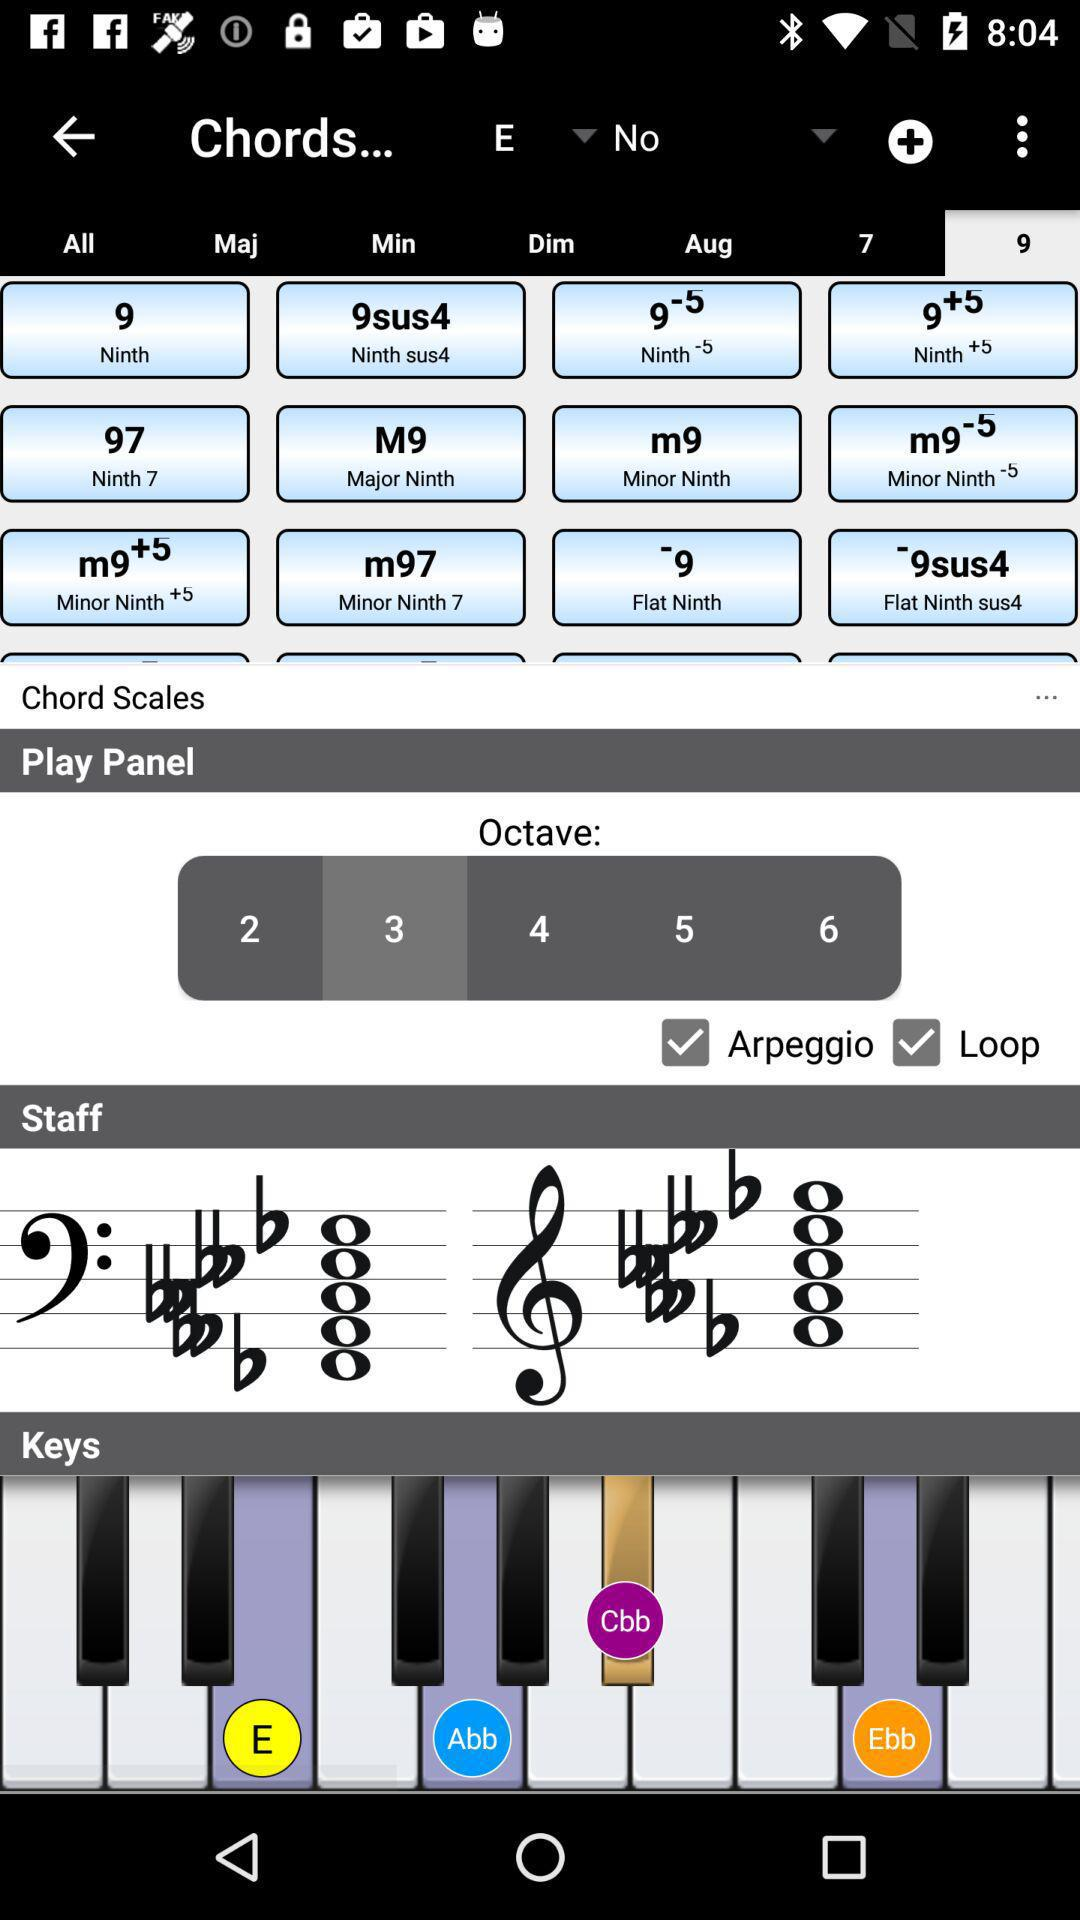What is the status of "Arpeggio" and "Loop"? "Arpeggio" and "Loop" are turned on. 